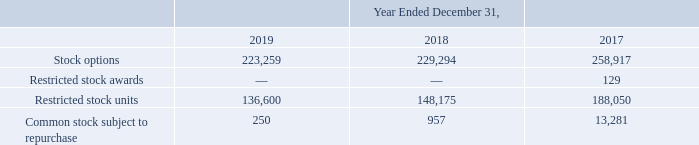The following securities have been excluded from the calculation of diluted weighted average common shares outstanding as the inclusion of these securities would have an anti-dilutive effect:
Participating securities are composed of certain stock options granted under the 2015 Plan, and previously granted under the 2009 Equity Incentive Plan, that may be exercised before the options have vested. Unvested shares have a non-forfeitable right to dividends. Unvested shares issued as a result of early exercise are subject to repurchase by us upon termination of employment or services at the original exercise price. The common stock subject to repurchase is no longer classified as participating securities when shares revert to common stock outstanding as the awards vest and our repurchase right lapses.
Our redeemable noncontrolling interest relates to our 85% equity ownership interest in OpenEye. The OpenEye stockholder agreement contains a put option that gives the minority OpenEye stockholders the right to sell their OpenEye shares to us based on the fair value of the shares. The OpenEye stockholder agreement also contains a call option that gives us the right to purchase the remaining OpenEye shares from the minority OpenEye stockholders based on the fair value of the shares. The put and call options can each be exercised beginning in the first quarter of 2023. This redeemable noncontrolling interest is considered temporary equity and we report it between liabilities and stockholders’ equity in the consolidated balance sheets. The amount of the net income or loss attributable to redeemable noncontrolling interests is recorded in the consolidated statements of operations.
What were participating securities composed of? Certain stock options granted under the 2015 plan, and previously granted under the 2009 equity incentive plan, that may be exercised before the options have vested. What was the company's equity ownership interest in OpenEye?
Answer scale should be: percent. 85. How much were the Restricted stock units in 2019? 136,600. What was the change in Common stock subject to repurchase between 2018 and 2017? 957-13,281
Answer: -12324. How many years did restricted stock units exceed 150,000? 2017
Answer: 1. What was the percentage change in Common stock subject to repurchase between 2018 and 2019?
Answer scale should be: percent. (250-957)/957
Answer: -73.88. 